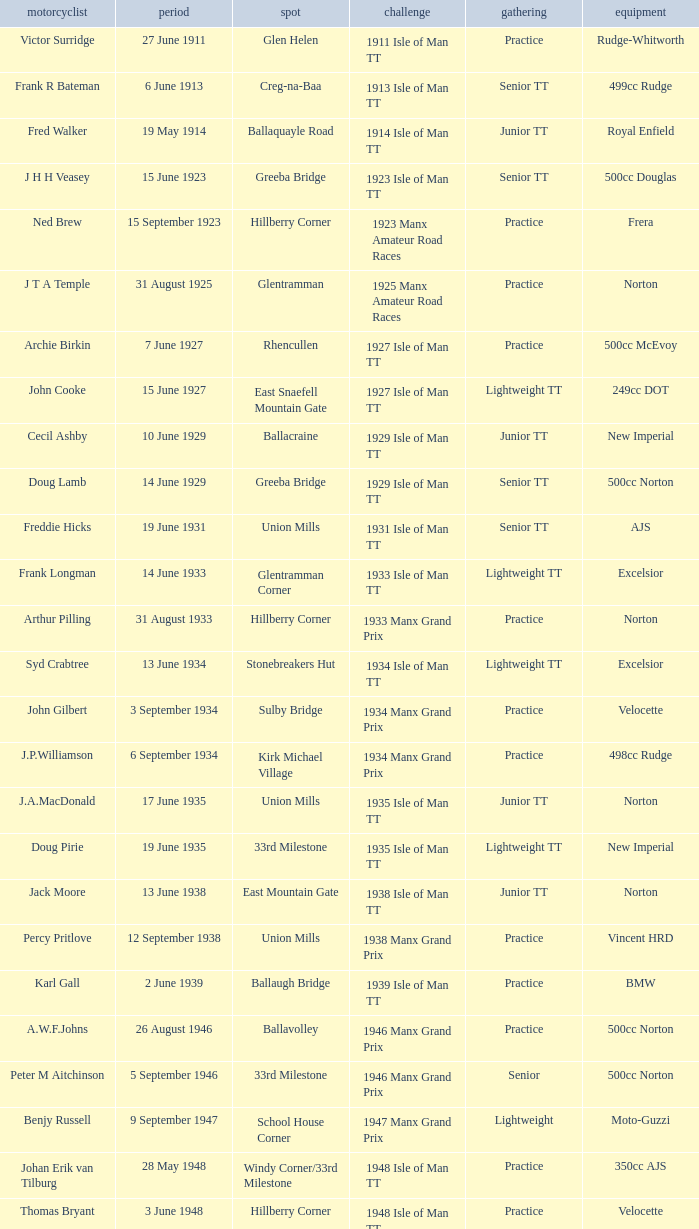Where was the 249cc Yamaha? Glentramman. 